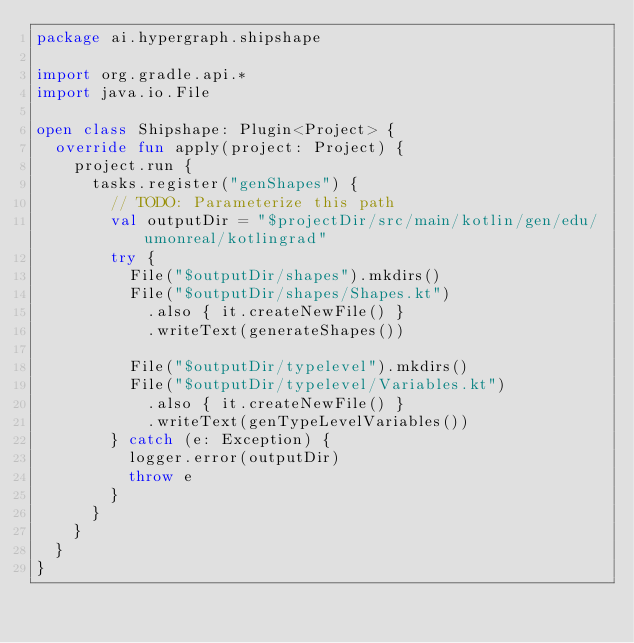<code> <loc_0><loc_0><loc_500><loc_500><_Kotlin_>package ai.hypergraph.shipshape

import org.gradle.api.*
import java.io.File

open class Shipshape: Plugin<Project> {
  override fun apply(project: Project) {
    project.run {
      tasks.register("genShapes") {
        // TODO: Parameterize this path
        val outputDir = "$projectDir/src/main/kotlin/gen/edu/umonreal/kotlingrad"
        try {
          File("$outputDir/shapes").mkdirs()
          File("$outputDir/shapes/Shapes.kt")
            .also { it.createNewFile() }
            .writeText(generateShapes())

          File("$outputDir/typelevel").mkdirs()
          File("$outputDir/typelevel/Variables.kt")
            .also { it.createNewFile() }
            .writeText(genTypeLevelVariables())
        } catch (e: Exception) {
          logger.error(outputDir)
          throw e
        }
      }
    }
  }
}
</code> 